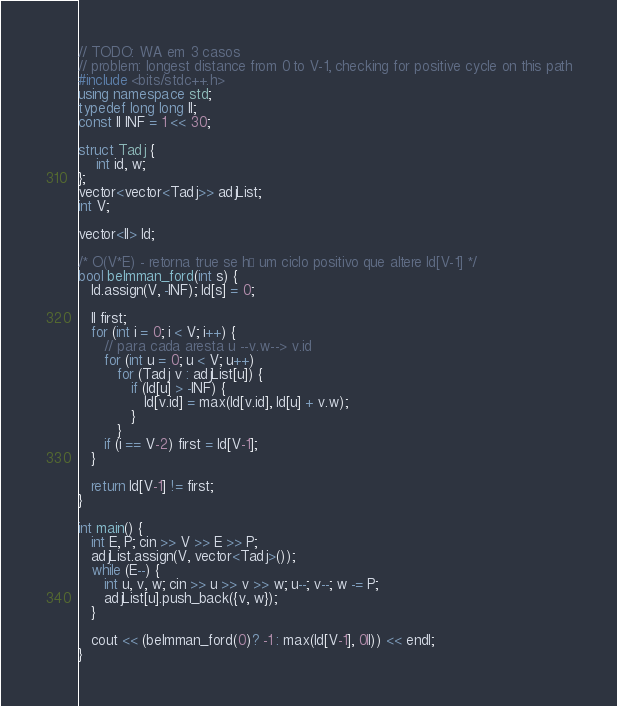Convert code to text. <code><loc_0><loc_0><loc_500><loc_500><_C++_>// TODO: WA em 3 casos
// problem: longest distance from 0 to V-1, checking for positive cycle on this path
#include <bits/stdc++.h>
using namespace std;
typedef long long ll;
const ll INF = 1 << 30;

struct Tadj {
	int id, w;
};
vector<vector<Tadj>> adjList;
int V;

vector<ll> ld;

/* O(V*E) - retorna true se há um ciclo positivo que altere ld[V-1] */
bool belmman_ford(int s) {
   ld.assign(V, -INF); ld[s] = 0;

   ll first;
   for (int i = 0; i < V; i++) {
      // para cada aresta u --v.w--> v.id
      for (int u = 0; u < V; u++)
         for (Tadj v : adjList[u]) {
            if (ld[u] > -INF) {
               ld[v.id] = max(ld[v.id], ld[u] + v.w);
            }
         }
      if (i == V-2) first = ld[V-1];
   }

   return ld[V-1] != first; 
}

int main() {
   int E, P; cin >> V >> E >> P;
   adjList.assign(V, vector<Tadj>());
   while (E--) {
      int u, v, w; cin >> u >> v >> w; u--; v--; w -= P;
      adjList[u].push_back({v, w});
   }

   cout << (belmman_ford(0)? -1 : max(ld[V-1], 0ll)) << endl;
}</code> 